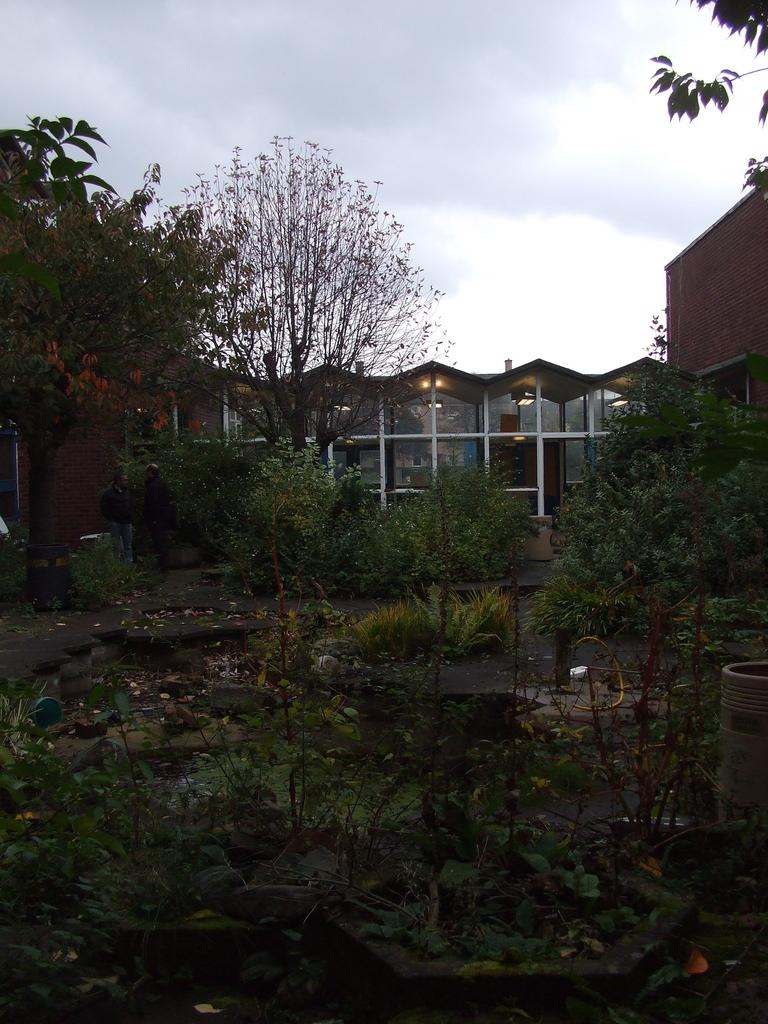What type of living organisms can be seen in the image? Plants and trees are visible in the image. What can be found on the ground in the image? There are stones on the ground in the image. What type of structure is present in the image? There is a building in the image. What else can be seen in the image besides plants and trees? There are lights and some objects in the image. What is visible in the background of the image? The sky is visible in the background of the image. How does the current affect the plants in the image? There is no reference to a current or water in the image, so it is not possible to answer that question. 